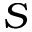Convert formula to latex. <formula><loc_0><loc_0><loc_500><loc_500>S</formula> 